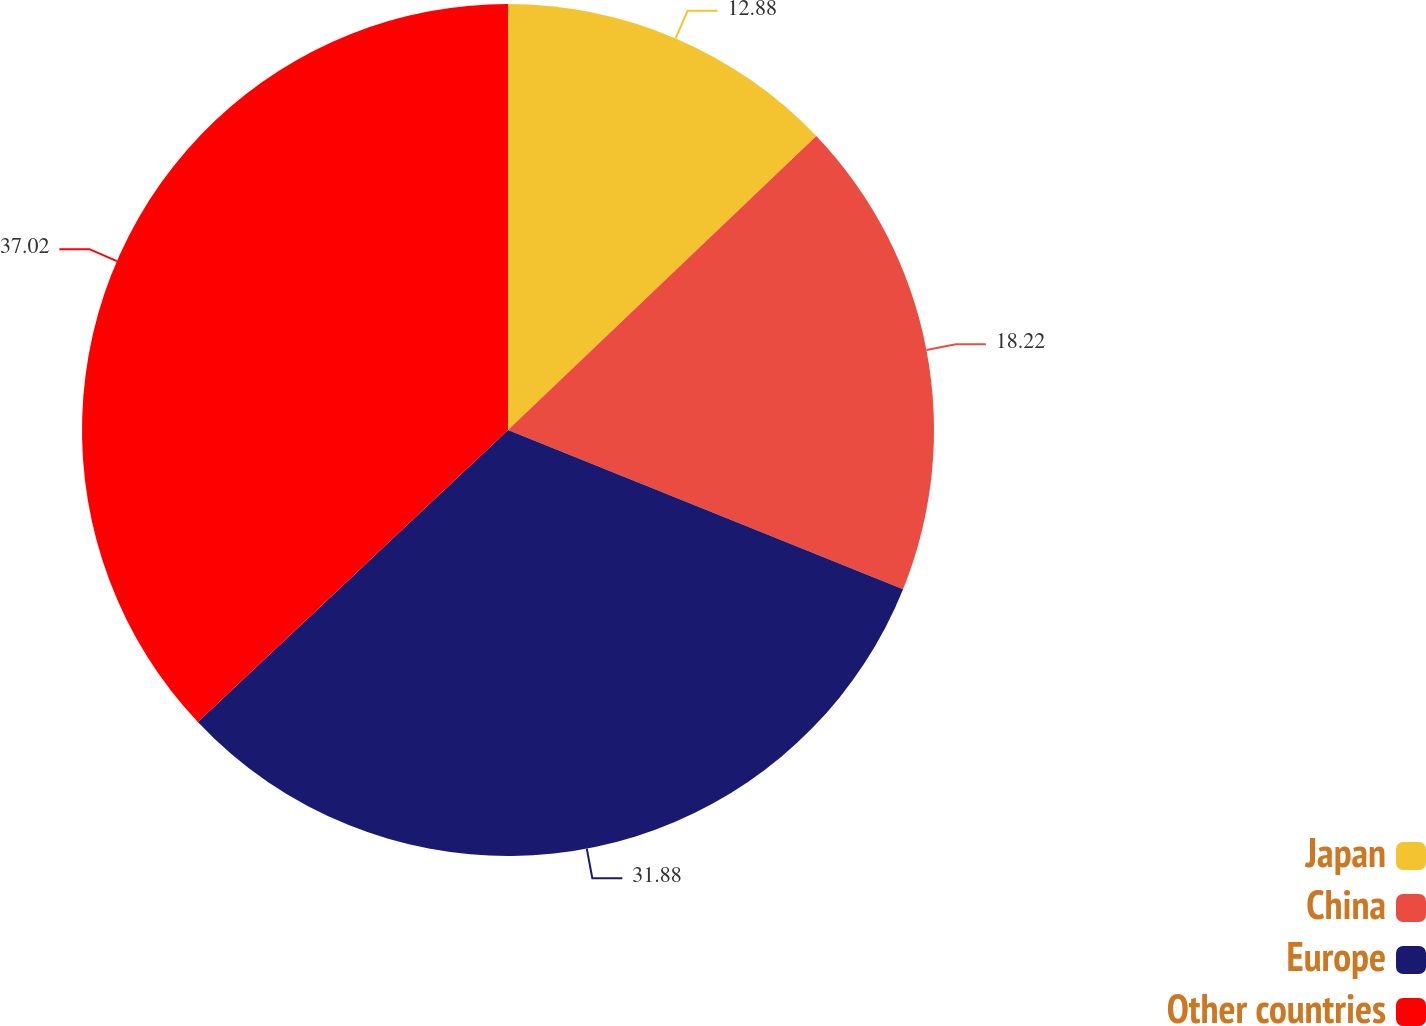Convert chart to OTSL. <chart><loc_0><loc_0><loc_500><loc_500><pie_chart><fcel>Japan<fcel>China<fcel>Europe<fcel>Other countries<nl><fcel>12.88%<fcel>18.22%<fcel>31.88%<fcel>37.02%<nl></chart> 